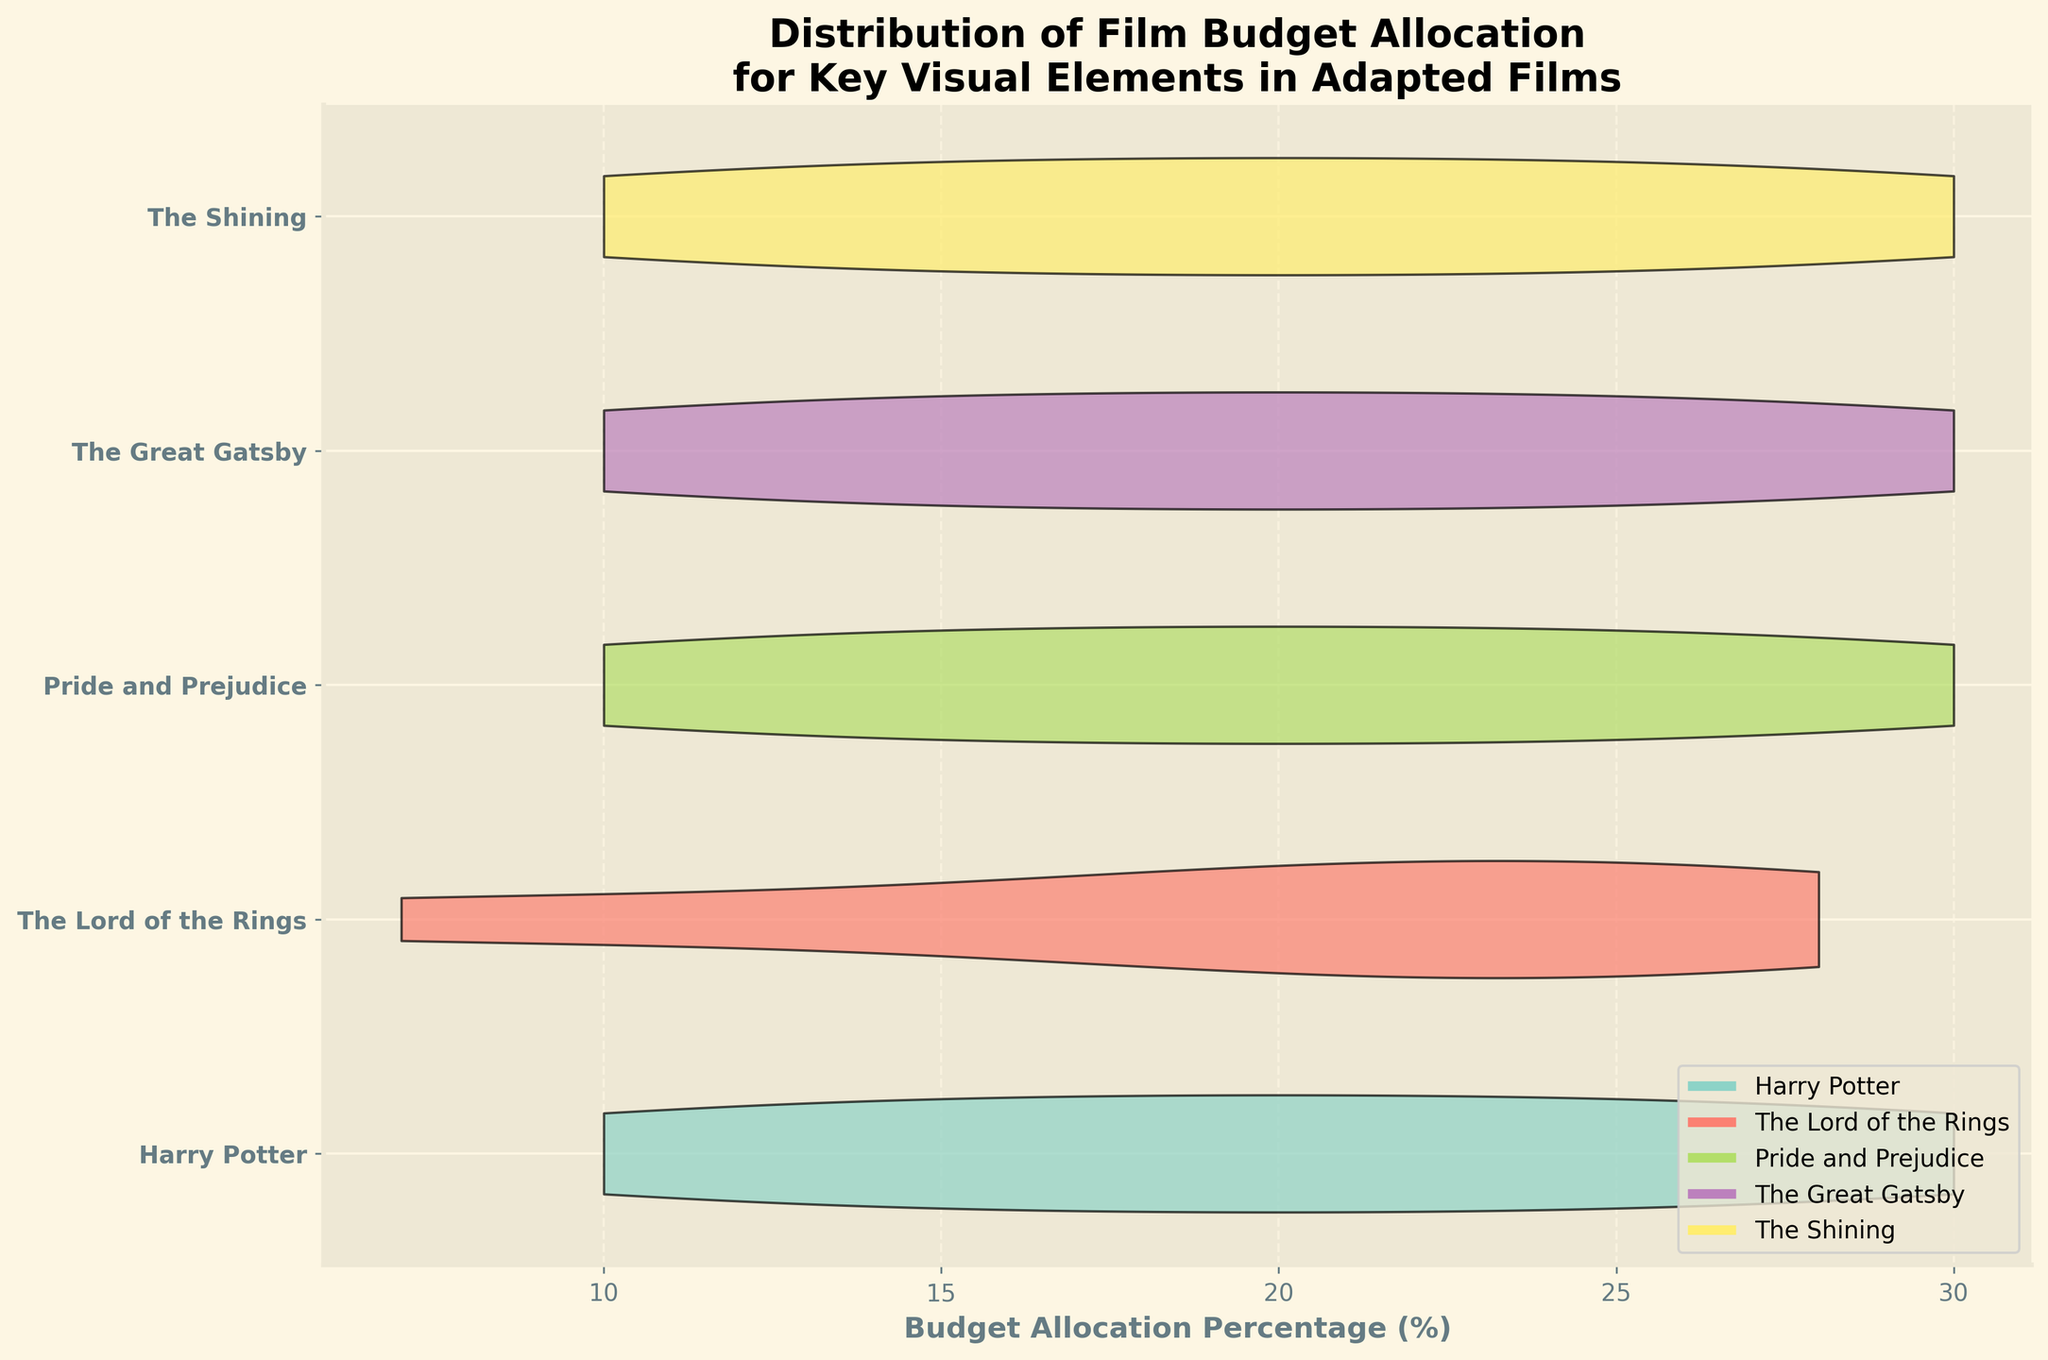What is the title of the plot? The title of the chart is at the top and it reads "Distribution of Film Budget Allocation for Key Visual Elements in Adapted Films".
Answer: Distribution of Film Budget Allocation for Key Visual Elements in Adapted Films What does the x-axis represent? The x-axis represents the budget allocation percentage (%) for different visual elements in the films.
Answer: Budget Allocation Percentage (%) Which film has the highest budget allocation for Lighting? Looking at the plot, "Pride and Prejudice" has the highest budget allocation for Lighting, which is apparent as the highest point in the violin plot for Lighting is at 30%.
Answer: Pride and Prejudice Which two films have the closest budget allocation percentage for Special Effects? By comparing the violin plots for Special Effects, "Harry Potter" and "The Great Gatsby" have similar budget allocation percentages around 25-30% for this category.
Answer: Harry Potter and The Great Gatsby In terms of Set Design, which film allocates the least percentage of its budget? Observing the violin plots for Set Design, "Pride and Prejudice" allocates the least budget percentage at around 20%.
Answer: Pride and Prejudice What is the general trend observed for budget allocation in Costume Design among the films? Most films appear to allocate a moderate percentage of their budget to Costume Design, ranging roughly from 10% to 25%, with slight variations.
Answer: Moderate allocation, 10%-25% How does "The Shining" distribute its budget among the visual elements? "The Shining" allocates 25% to Set Design, 10% to Costume Design, 30% to Cinematography, 20% to Special Effects, and 15% to Lighting as visible from the violin plot.
Answer: 25%, 10%, 30%, 20%, 15% Which visual element seems to have the most varied budget allocation across all films? By looking at the range and spread of the violin plots, Lighting shows the most varied budget allocation across all films.
Answer: Lighting Which film allocates a considerably high percentage of its budget on Cinematography compared to others? "The Shining" allocates a significantly higher percentage to Cinematography at 30%, which is visibly more than other films.
Answer: The Shining Is there a visual element where each film has an almost close budget allocation percentage? Comparing the violin plots, Special Effects allocations are somewhat close among the films, generally falling between 20% to 30%.
Answer: Special Effects 